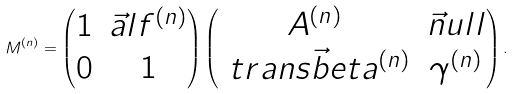<formula> <loc_0><loc_0><loc_500><loc_500>M ^ { ( n ) } = \begin{pmatrix} 1 & \vec { a } l f ^ { ( n ) } \\ 0 & 1 \end{pmatrix} \begin{pmatrix} A ^ { ( n ) } & \vec { n } u l l \\ \ t r a n s \vec { b } e t a ^ { ( n ) } & \gamma ^ { ( n ) } \end{pmatrix} .</formula> 